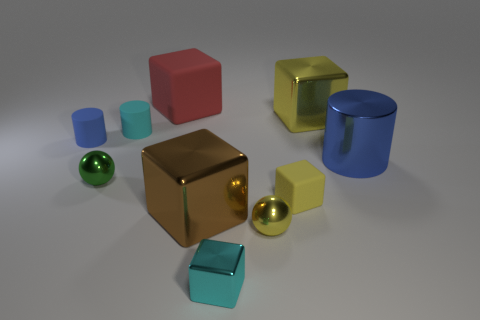Do the yellow matte object and the big shiny thing that is in front of the large cylinder have the same shape?
Your answer should be very brief. Yes. How many things are either blue things that are to the right of the big red matte thing or matte objects that are on the left side of the brown thing?
Make the answer very short. 4. The small matte thing that is the same color as the metal cylinder is what shape?
Give a very brief answer. Cylinder. What is the shape of the shiny object that is right of the big yellow object?
Give a very brief answer. Cylinder. There is a yellow shiny thing on the right side of the tiny yellow shiny ball; does it have the same shape as the cyan shiny object?
Offer a very short reply. Yes. How many objects are large shiny blocks in front of the cyan matte object or brown cylinders?
Make the answer very short. 1. What color is the other large metal object that is the same shape as the big brown thing?
Offer a very short reply. Yellow. Is there anything else that has the same color as the tiny shiny cube?
Provide a succinct answer. Yes. There is a cylinder left of the green thing; what size is it?
Provide a succinct answer. Small. Do the big cylinder and the tiny rubber cylinder that is left of the cyan rubber cylinder have the same color?
Provide a succinct answer. Yes. 